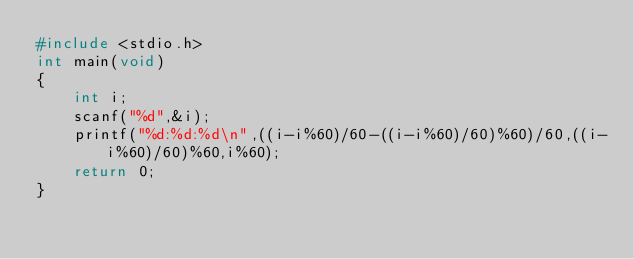<code> <loc_0><loc_0><loc_500><loc_500><_C_>#include <stdio.h>
int main(void)
{
    int i;
    scanf("%d",&i);
    printf("%d:%d:%d\n",((i-i%60)/60-((i-i%60)/60)%60)/60,((i-i%60)/60)%60,i%60);
    return 0;
}
</code> 